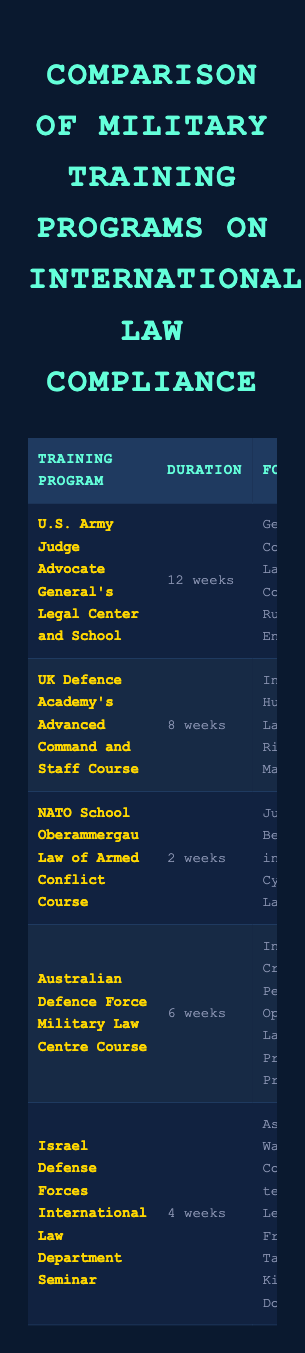What is the duration of the U.S. Army Judge Advocate General's Legal Center and School program? The table clearly indicates that the duration of the U.S. Army Judge Advocate General's Legal Center and School program is 12 weeks.
Answer: 12 weeks Which training program requires the shortest duration? By scanning the "Duration" column, the NATO School Oberammergau Law of Armed Conflict Course has the shortest duration of 2 weeks, compared to all other programs listed.
Answer: 2 weeks Is the UK Defence Academy's Advanced Command and Staff Course certified? According to the "Certification" column, the UK Defence Academy's Advanced Command and Staff Course indeed has an associated certification called the Advanced Staff Officer Diploma.
Answer: Yes How many training programs offer practical exercises involving simulations? Three training programs have practical exercises that include simulations listed in the "Practical Exercises" column: the U.S. Army program, the Israel Defense Forces seminar, and the Australian Defence Force program.
Answer: Three What is the average duration of all training programs listed? To calculate the average duration, first convert each duration into weeks: 12, 8, 2, 6, and 4. The total is 32 weeks. Dividing by the number of programs (5) gives an average duration of 32/5 = 6.4 weeks.
Answer: 6.4 weeks Which program focuses on Cyber Warfare Law? The "Focus Areas" column indicates that the NATO School Oberammergau Law of Armed Conflict Course specifically lists Cyber Warfare Law as one of its focus areas.
Answer: NATO School Oberammergau Law of Armed Conflict Course Do all training programs have annual updates? Checking the "Annual Updates" column reveals that while most programs indicate "Yes," it is important to confirm that there are no exceptions listed. Thus, yes, all programs do provide annual updates in some form.
Answer: Yes Which training program collaborates with Commonwealth nations? The International Collaboration column shows that the UK Defence Academy's Advanced Command and Staff Course is the program that engages in joint exercises with Commonwealth nations.
Answer: UK Defence Academy's Advanced Command and Staff Course How many programs focus on International Humanitarian Law? The "Focus Areas" column reveals that there is only one training program specifically focusing on International Humanitarian Law, which is the UK Defence Academy's Advanced Command and Staff Course.
Answer: One What compliance standards does the Israeli Defense Forces program adhere to? The "Compliance Standards" column specifies that the Israeli Defense Forces International Law Department Seminar adheres to Israeli Supreme Court rulings and customary international law.
Answer: Israeli Supreme Court rulings, customary international law 